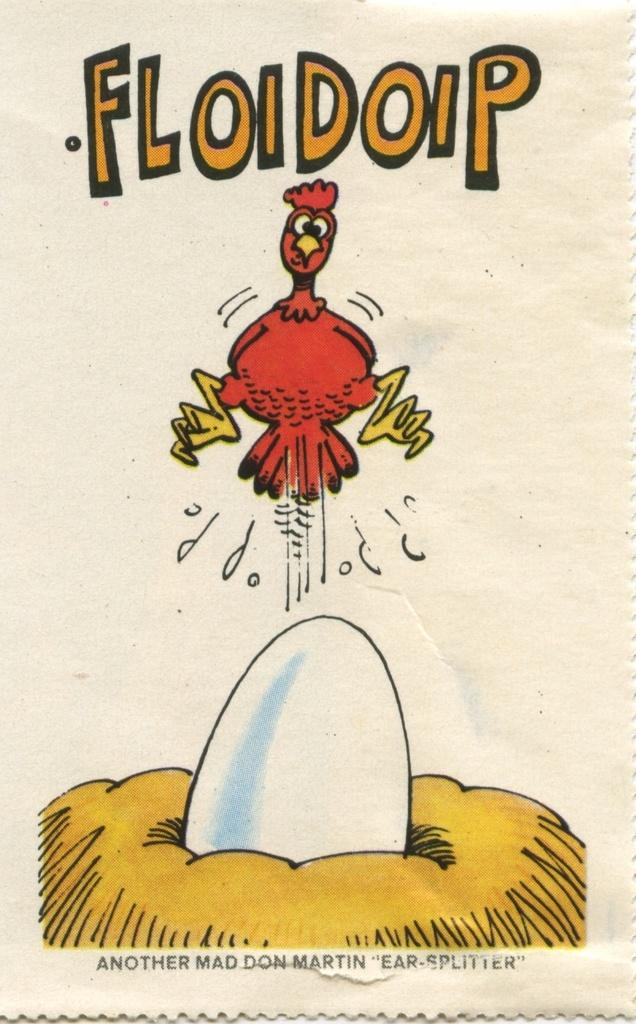What is the main subject of the poster in the image? The main subject of the poster in the image is a cartoon image of a hen in the center. Are there any other cartoon images on the poster? Yes, there is a cartoon image of an egg on a net at the bottom of the poster. What type of organization is depicted on the poster? There is no organization depicted on the poster; it features cartoon images of a hen and an egg. Can you see a beetle crawling on the poster? There is no beetle present on the poster; it only features cartoon images of a hen and an egg. 